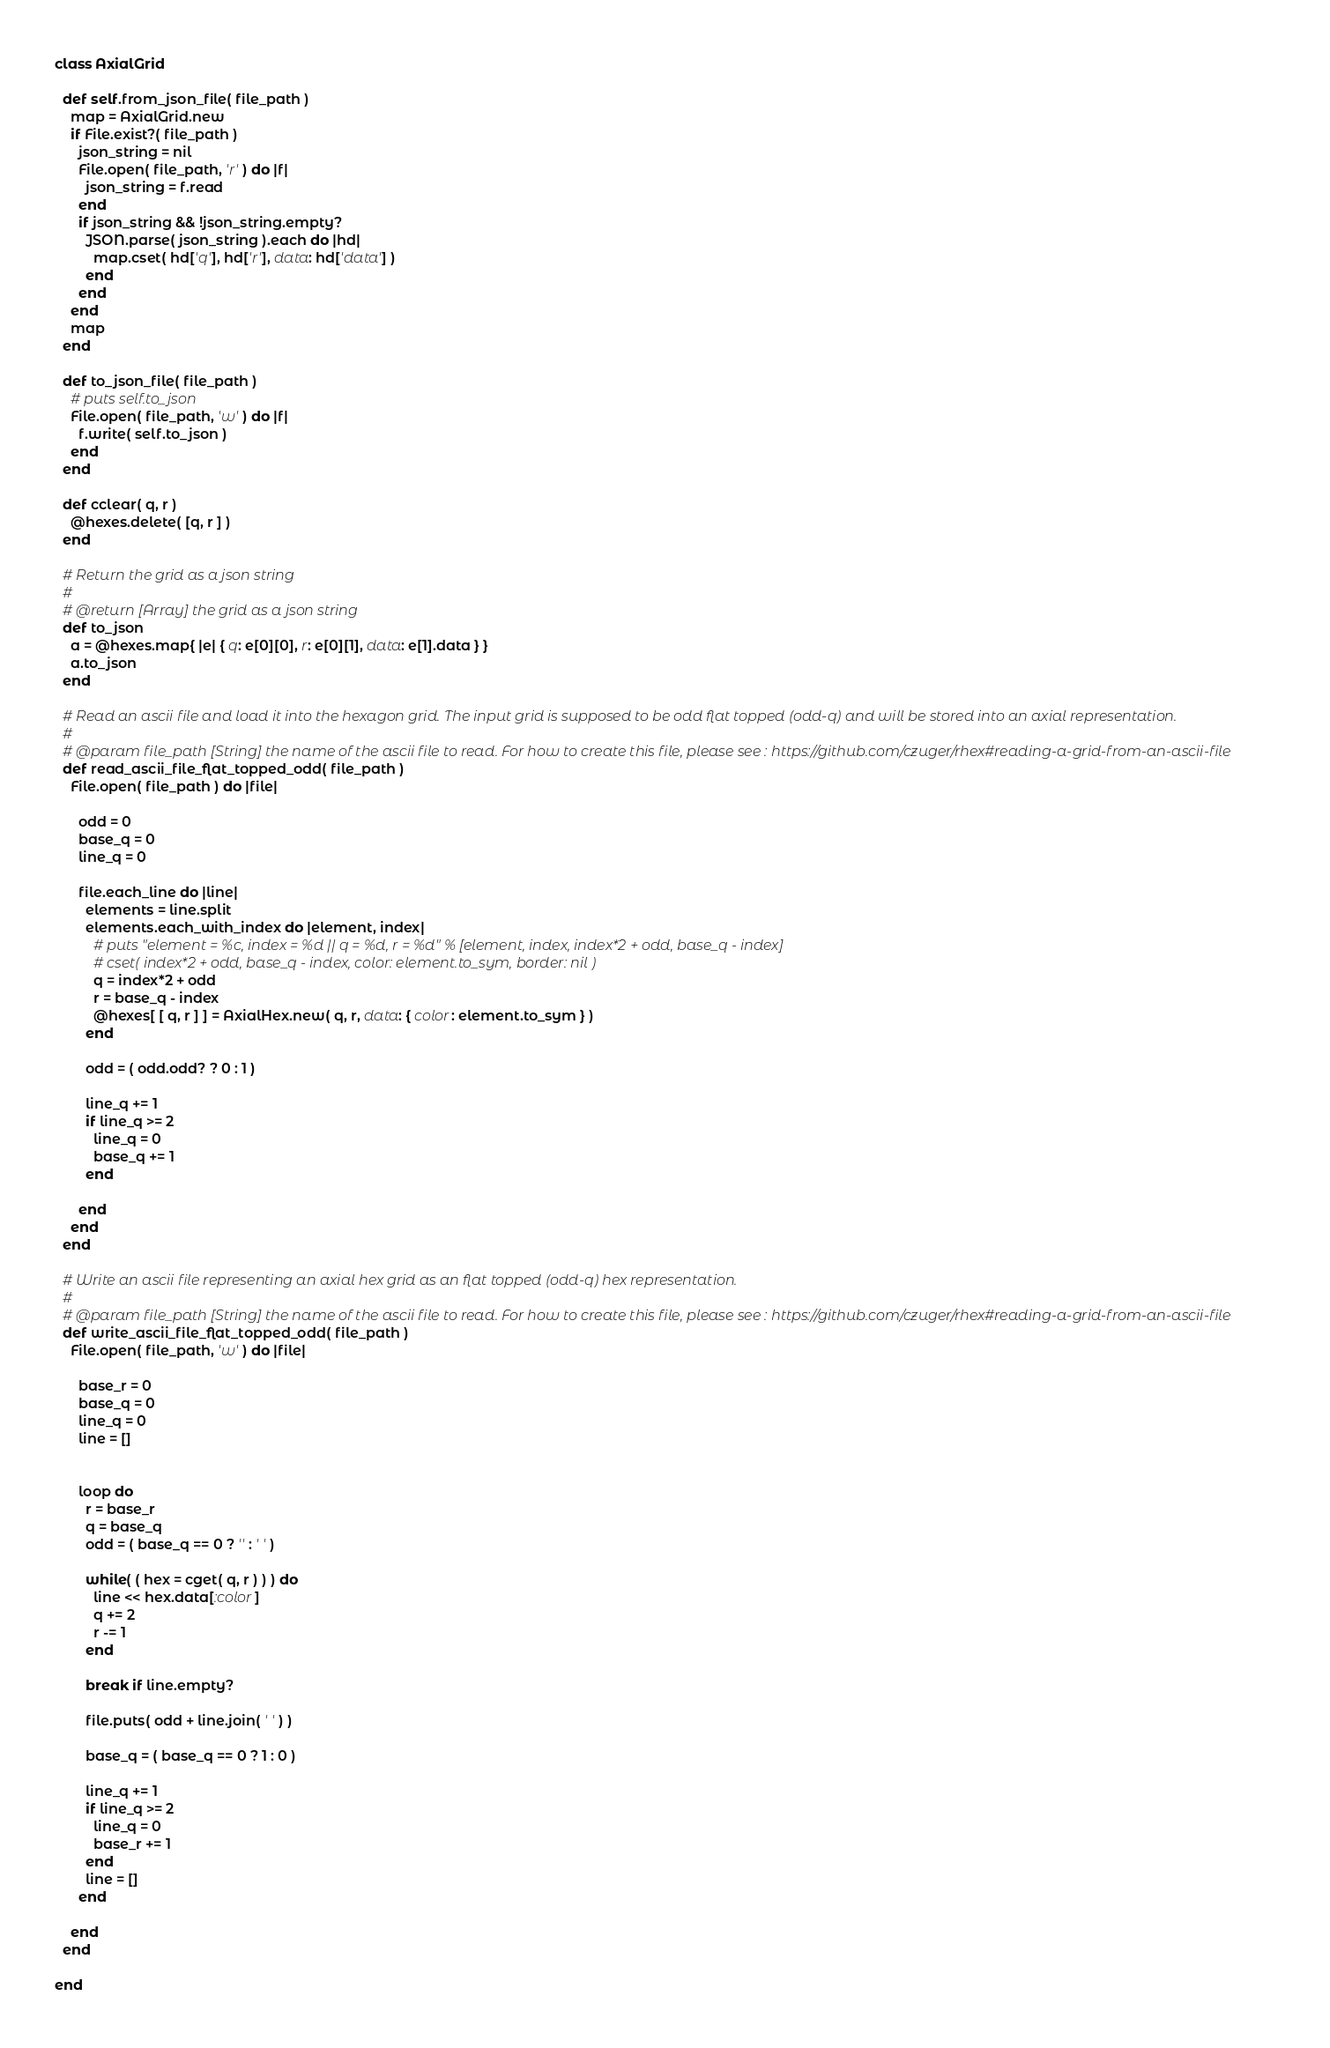Convert code to text. <code><loc_0><loc_0><loc_500><loc_500><_Ruby_>class AxialGrid

  def self.from_json_file( file_path )
    map = AxialGrid.new
    if File.exist?( file_path )
      json_string = nil
      File.open( file_path, 'r' ) do |f|
        json_string = f.read
      end
      if json_string && !json_string.empty?
        JSON.parse( json_string ).each do |hd|
          map.cset( hd['q'], hd['r'], data: hd['data'] )
        end
      end
    end
    map
  end

  def to_json_file( file_path )
    # puts self.to_json
    File.open( file_path, 'w' ) do |f|
      f.write( self.to_json )
    end
  end

  def cclear( q, r )
    @hexes.delete( [q, r ] )
  end

  # Return the grid as a json string
  #
  # @return [Array] the grid as a json string
  def to_json
    a = @hexes.map{ |e| { q: e[0][0], r: e[0][1], data: e[1].data } }
    a.to_json
  end

  # Read an ascii file and load it into the hexagon grid. The input grid is supposed to be odd flat topped (odd-q) and will be stored into an axial representation.
  #
  # @param file_path [String] the name of the ascii file to read. For how to create this file, please see : https://github.com/czuger/rhex#reading-a-grid-from-an-ascii-file
  def read_ascii_file_flat_topped_odd( file_path )
    File.open( file_path ) do |file|

      odd = 0
      base_q = 0
      line_q = 0

      file.each_line do |line|
        elements = line.split
        elements.each_with_index do |element, index|
          # puts "element = %c, index = %d || q = %d, r = %d" % [element, index, index*2 + odd, base_q - index]
          # cset( index*2 + odd, base_q - index, color: element.to_sym, border: nil )
          q = index*2 + odd
          r = base_q - index
          @hexes[ [ q, r ] ] = AxialHex.new( q, r, data: { color: element.to_sym } )
        end

        odd = ( odd.odd? ? 0 : 1 )

        line_q += 1
        if line_q >= 2
          line_q = 0
          base_q += 1
        end

      end
    end
  end

  # Write an ascii file representing an axial hex grid as an flat topped (odd-q) hex representation.
  #
  # @param file_path [String] the name of the ascii file to read. For how to create this file, please see : https://github.com/czuger/rhex#reading-a-grid-from-an-ascii-file
  def write_ascii_file_flat_topped_odd( file_path )
    File.open( file_path, 'w' ) do |file|

      base_r = 0
      base_q = 0
      line_q = 0
      line = []


      loop do
        r = base_r
        q = base_q
        odd = ( base_q == 0 ? '' : ' ' )

        while( ( hex = cget( q, r ) ) ) do
          line << hex.data[:color]
          q += 2
          r -= 1
        end

        break if line.empty?

        file.puts( odd + line.join( ' ' ) )

        base_q = ( base_q == 0 ? 1 : 0 )

        line_q += 1
        if line_q >= 2
          line_q = 0
          base_r += 1
        end
        line = []
      end

    end
  end

end</code> 